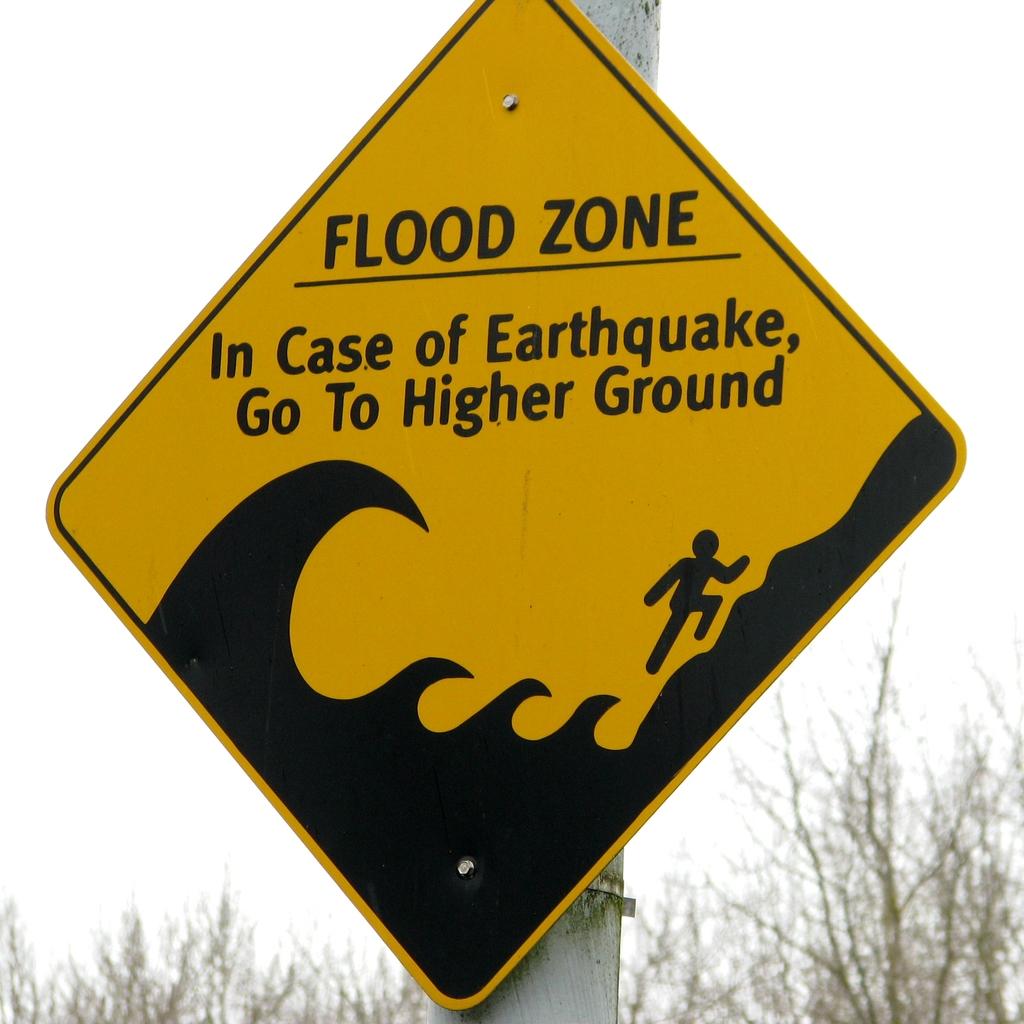Where do you go if there is an earthquake?
Your response must be concise. Higher ground. What type of sign is this?
Make the answer very short. Flood zone. 